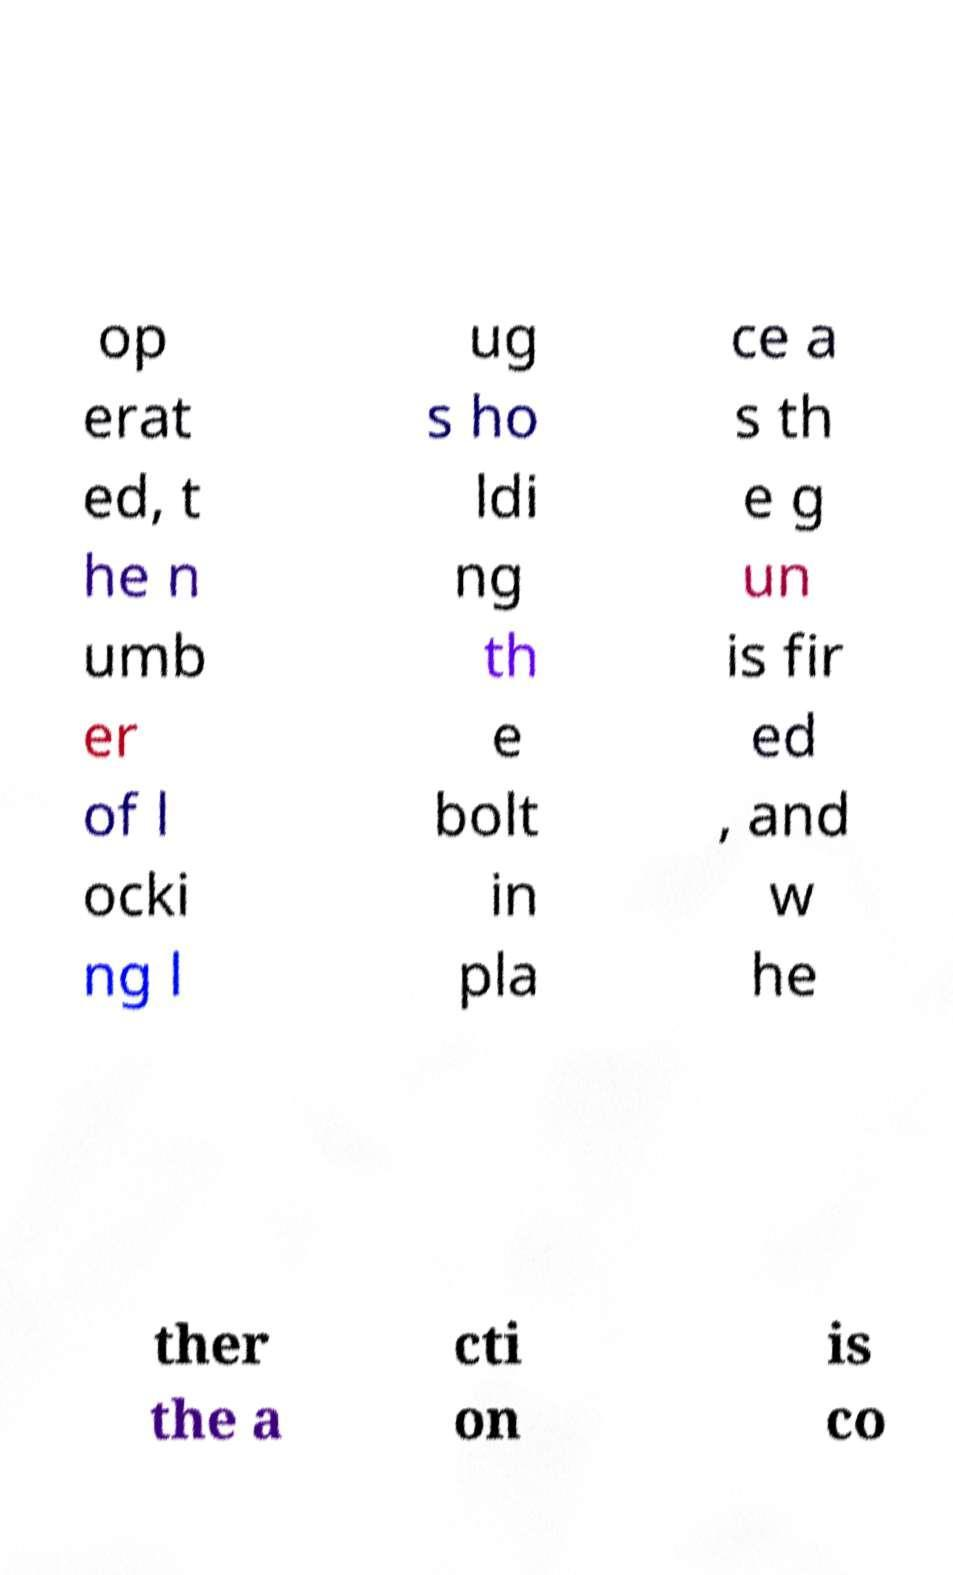For documentation purposes, I need the text within this image transcribed. Could you provide that? op erat ed, t he n umb er of l ocki ng l ug s ho ldi ng th e bolt in pla ce a s th e g un is fir ed , and w he ther the a cti on is co 